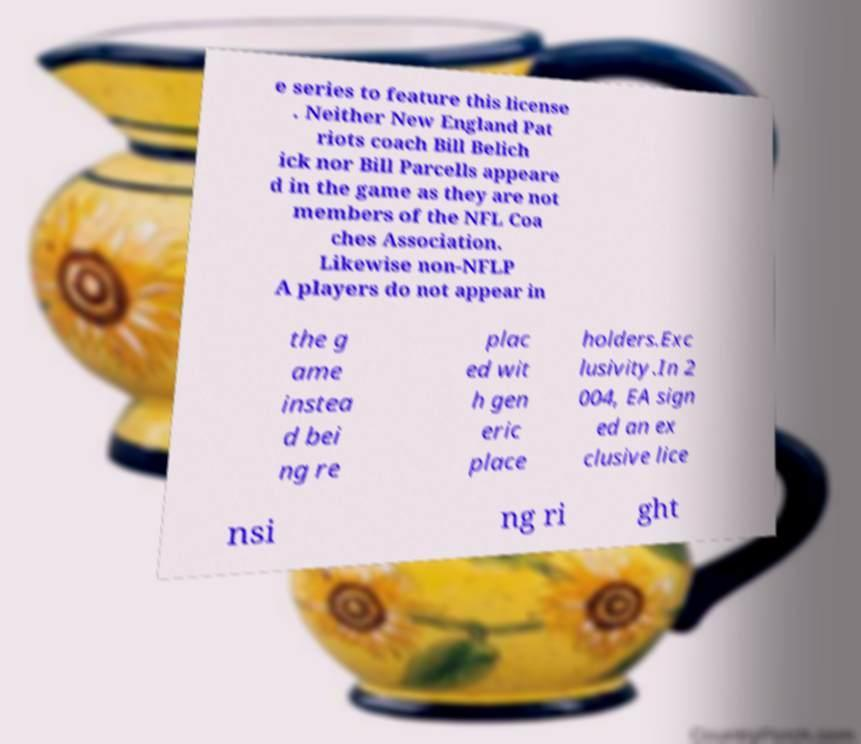Please identify and transcribe the text found in this image. e series to feature this license . Neither New England Pat riots coach Bill Belich ick nor Bill Parcells appeare d in the game as they are not members of the NFL Coa ches Association. Likewise non-NFLP A players do not appear in the g ame instea d bei ng re plac ed wit h gen eric place holders.Exc lusivity.In 2 004, EA sign ed an ex clusive lice nsi ng ri ght 